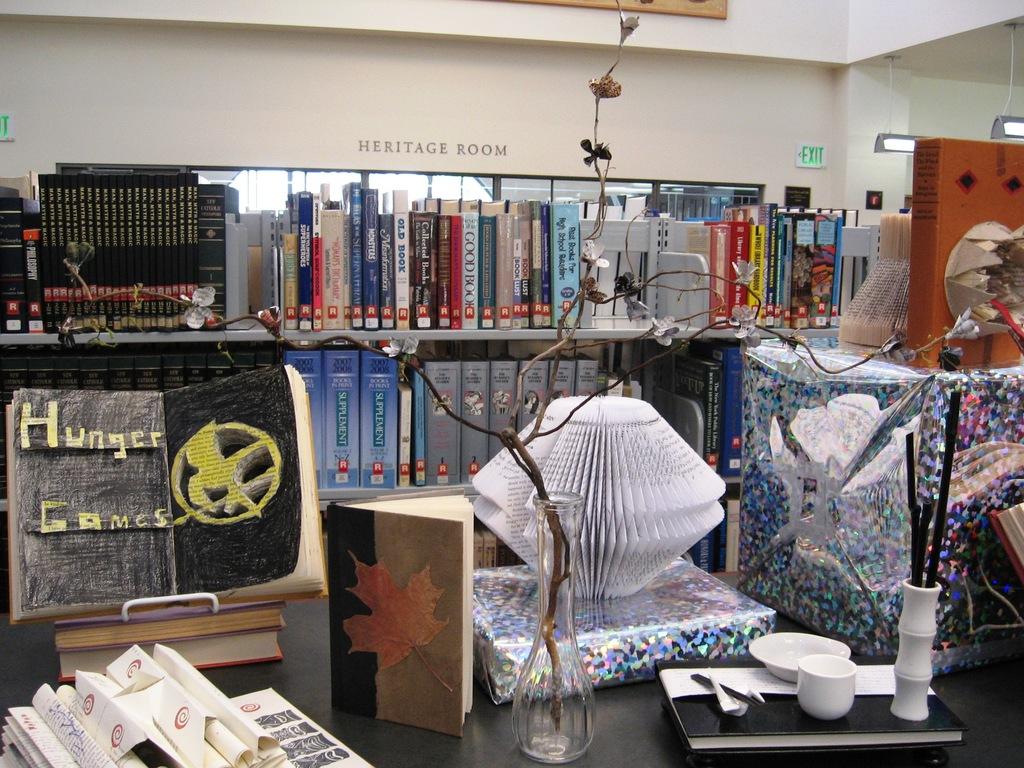What do the yellow letters say?
Provide a succinct answer. Hunger games. What does it say on the wall above the shelf?
Ensure brevity in your answer.  Heritage room. 